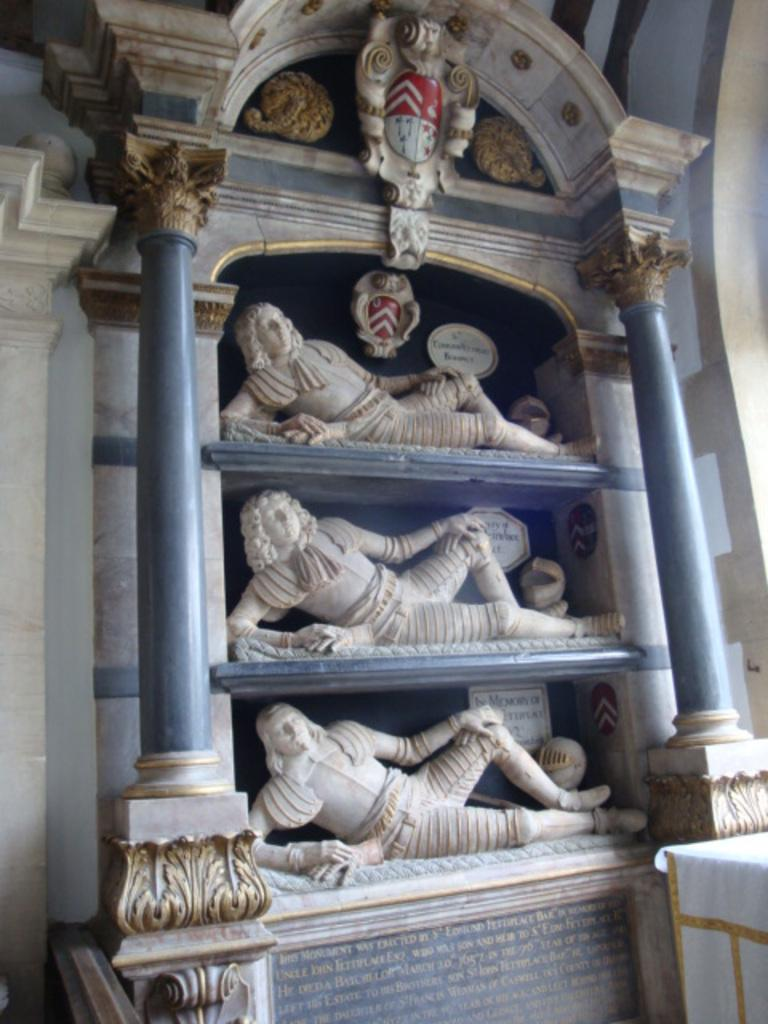What can be seen on the racks in the image? There are statues on the racks in the image. What architectural features are present in the image? There are pillars in the image. What is written on the wall below the racks? There is writing on the wall below the racks in the image. What other types of sculptures can be seen in the image? There are other sculptures on the wall in the image. How many dinosaurs are present on the racks in the image? There are no dinosaurs present on the racks in the image; the racks contain statues. What type of plate is used to serve the food in the image? There is no plate or food present in the image; it features statues, pillars, and writing. 